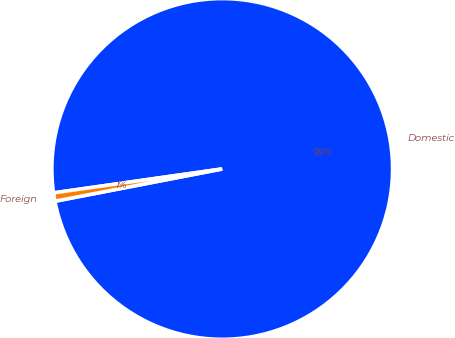Convert chart to OTSL. <chart><loc_0><loc_0><loc_500><loc_500><pie_chart><fcel>Domestic<fcel>Foreign<nl><fcel>99.21%<fcel>0.79%<nl></chart> 